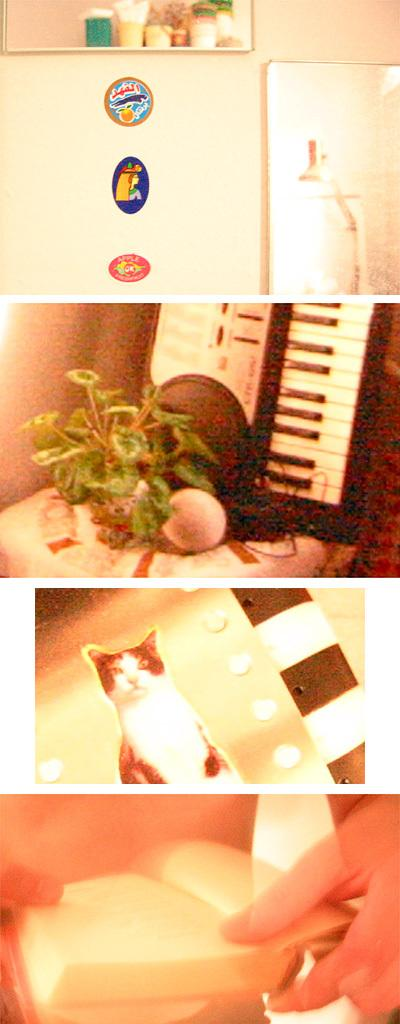What type of appliance can be seen in the image? There is a fridge in the image. What living organism is present in the image? There is a cat in the image. What non-living object can be seen in the image? There is a book in the image. What type of plant is visible in the image? There is a plant in the image. What type of rice is being cooked in the image? There is no rice present in the image. What historical event is depicted in the image? There is no historical event depicted in the image. 